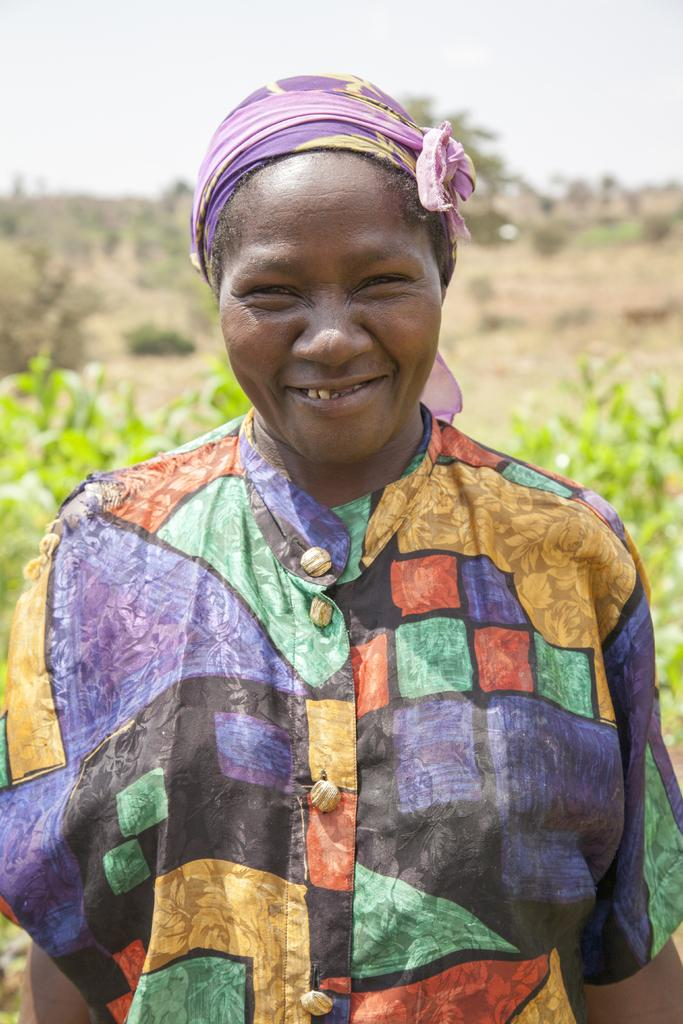Who is present in the image? There is a woman in the image. What is the woman's expression in the image? The woman is smiling in the image. What can be seen in the background of the image? There are plants in the background of the image. What is visible at the top of the image? The sky is visible at the top of the image. What type of wire is being used to support the woman's face in the image? There is no wire present in the image, and the woman's face is not being supported by any object. 